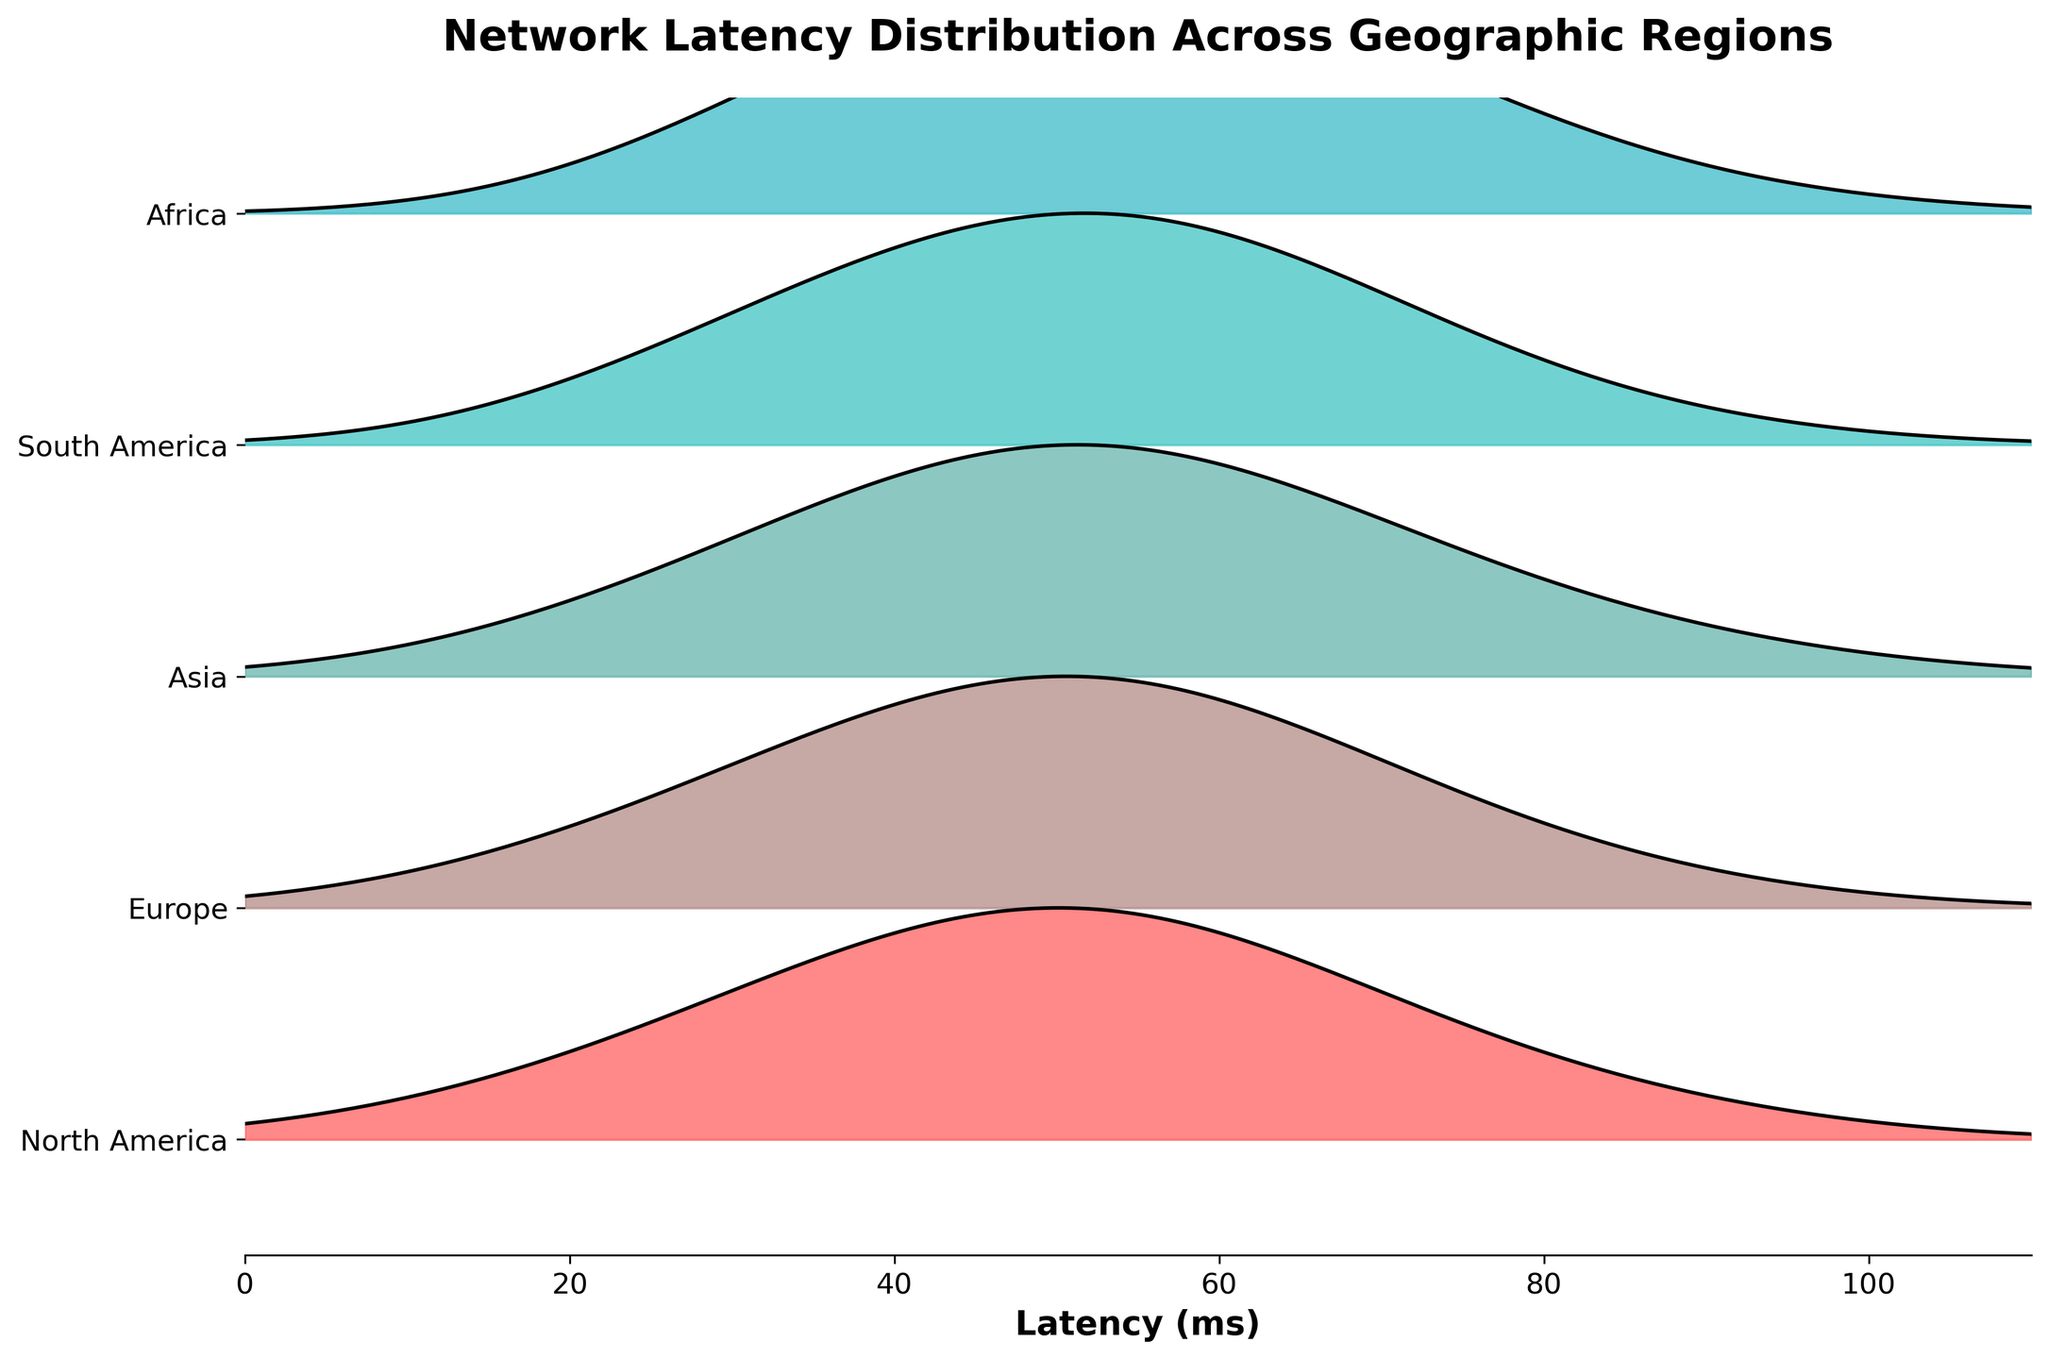What is the title of the plot? The title of the plot is “Network Latency Distribution Across Geographic Regions,” which is prominently displayed at the top.
Answer: Network Latency Distribution Across Geographic Regions Which region has the lowest latency range? By comparing the latency ranges displayed for each region in the plot, North America has the lowest latency range, starting from around 10 ms and peaking at 50 ms.
Answer: North America Which region shows the broadest spread of latency values? Observing the width of the latency distributions for each region, Africa shows the broadest spread of latency values, ranging from 30 ms to 100 ms.
Answer: Africa Approximately at what latency value does Asia have its peak density? Checking the plot for the peak density of the Asian region's distribution, Asia peaks at a latency of approximately 50 ms.
Answer: 50 ms How does the peak latency value of Europe compare to that of North America? The peak latency value of Europe is around 55 ms, whereas North America peaks at around 50 ms, indicating that Europe's peak latency is higher than North America's peak latency.
Answer: Europe’s peak latency is higher Which region exhibits the most consistent latency distribution, indicated by the narrowest peak? Looking for the region with the narrowest or most concentrated latency distribution, North America has the most consistent latency distribution with the peak around 50 ms.
Answer: North America What differences can be seen between the latency distributions of South America and Africa? South America has a peak latency at around 55 ms and a somewhat narrower spread from 25 ms to 95 ms, while Africa has a peak at 50 ms but a broader spread from 30 ms to 100 ms.
Answer: South America has a narrower spread What is the range of latency values in Europe? Observing Europe, it starts from around 15 ms and extends to approximately 95 ms.
Answer: 15 ms to 95 ms Which region has the least density at higher latencies (above 70 ms)? From the plot, North America has the least density at higher latencies since its density sharply drops after 70 ms.
Answer: North America How do the peaks of latency distributions vary across regions? Reviewing the plot, the peaks are around: North America (50 ms), Europe (55 ms), Asia (50 ms), South America (55 ms), Africa (50 ms).
Answer: Vary from 50 ms to 55 ms 